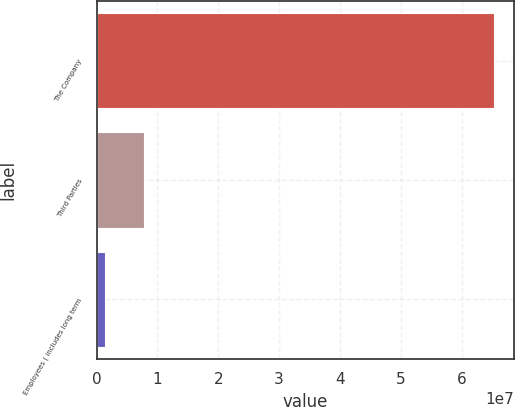<chart> <loc_0><loc_0><loc_500><loc_500><bar_chart><fcel>The Company<fcel>Third Parties<fcel>Employees ( includes long term<nl><fcel>6.54062e+07<fcel>7.78778e+06<fcel>1.38572e+06<nl></chart> 